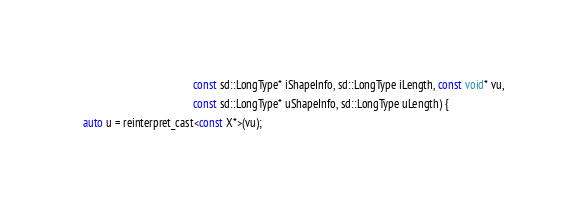Convert code to text. <code><loc_0><loc_0><loc_500><loc_500><_Cuda_>                                          const sd::LongType* iShapeInfo, sd::LongType iLength, const void* vu,
                                          const sd::LongType* uShapeInfo, sd::LongType uLength) {
  auto u = reinterpret_cast<const X*>(vu);</code> 